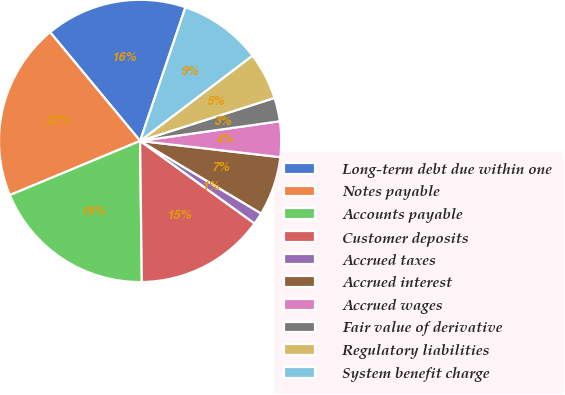Convert chart. <chart><loc_0><loc_0><loc_500><loc_500><pie_chart><fcel>Long-term debt due within one<fcel>Notes payable<fcel>Accounts payable<fcel>Customer deposits<fcel>Accrued taxes<fcel>Accrued interest<fcel>Accrued wages<fcel>Fair value of derivative<fcel>Regulatory liabilities<fcel>System benefit charge<nl><fcel>16.21%<fcel>20.27%<fcel>18.92%<fcel>14.86%<fcel>1.35%<fcel>6.76%<fcel>4.06%<fcel>2.7%<fcel>5.41%<fcel>9.46%<nl></chart> 